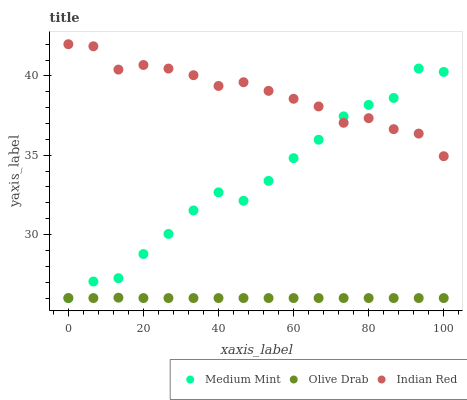Does Olive Drab have the minimum area under the curve?
Answer yes or no. Yes. Does Indian Red have the maximum area under the curve?
Answer yes or no. Yes. Does Indian Red have the minimum area under the curve?
Answer yes or no. No. Does Olive Drab have the maximum area under the curve?
Answer yes or no. No. Is Olive Drab the smoothest?
Answer yes or no. Yes. Is Medium Mint the roughest?
Answer yes or no. Yes. Is Indian Red the smoothest?
Answer yes or no. No. Is Indian Red the roughest?
Answer yes or no. No. Does Medium Mint have the lowest value?
Answer yes or no. Yes. Does Indian Red have the lowest value?
Answer yes or no. No. Does Indian Red have the highest value?
Answer yes or no. Yes. Does Olive Drab have the highest value?
Answer yes or no. No. Is Olive Drab less than Indian Red?
Answer yes or no. Yes. Is Indian Red greater than Olive Drab?
Answer yes or no. Yes. Does Indian Red intersect Medium Mint?
Answer yes or no. Yes. Is Indian Red less than Medium Mint?
Answer yes or no. No. Is Indian Red greater than Medium Mint?
Answer yes or no. No. Does Olive Drab intersect Indian Red?
Answer yes or no. No. 